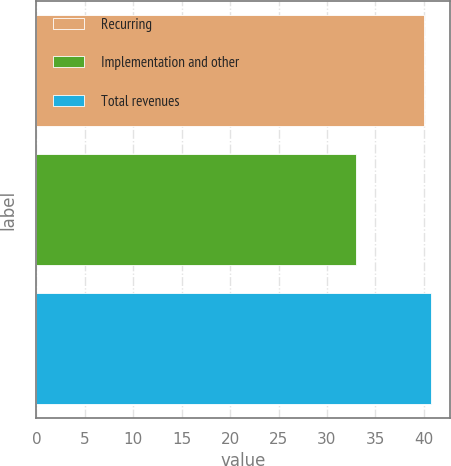Convert chart. <chart><loc_0><loc_0><loc_500><loc_500><bar_chart><fcel>Recurring<fcel>Implementation and other<fcel>Total revenues<nl><fcel>40<fcel>33<fcel>40.7<nl></chart> 